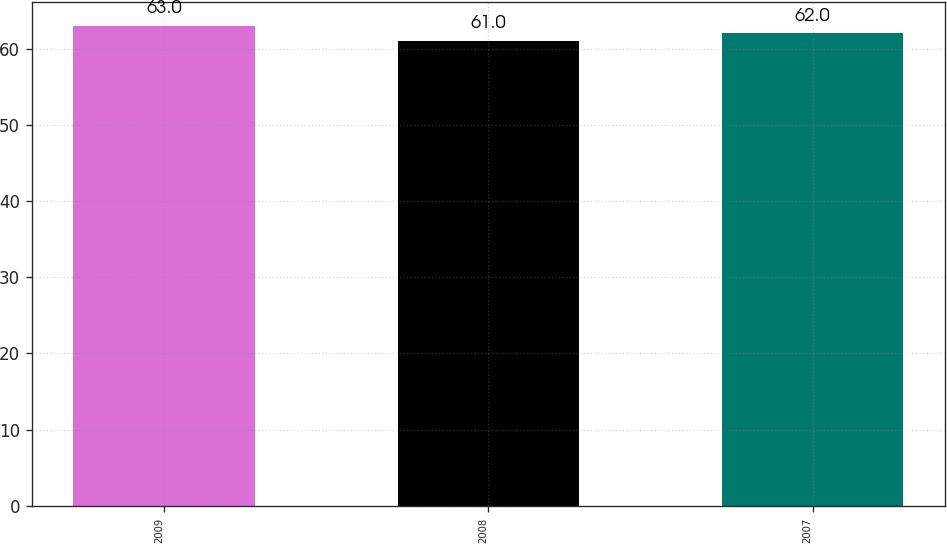<chart> <loc_0><loc_0><loc_500><loc_500><bar_chart><fcel>2009<fcel>2008<fcel>2007<nl><fcel>63<fcel>61<fcel>62<nl></chart> 